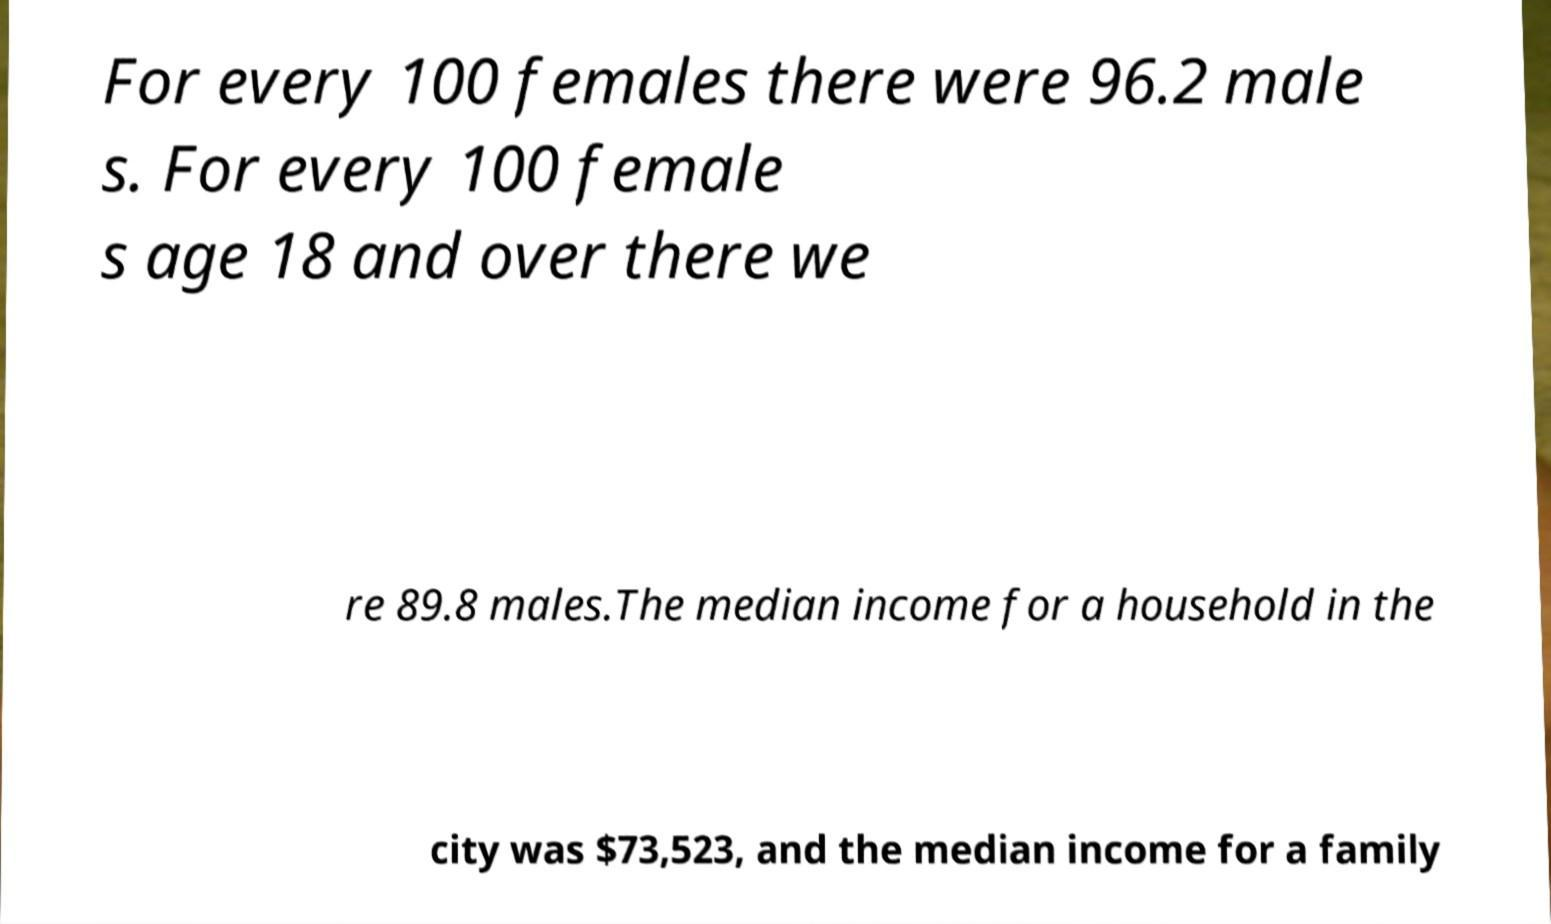I need the written content from this picture converted into text. Can you do that? For every 100 females there were 96.2 male s. For every 100 female s age 18 and over there we re 89.8 males.The median income for a household in the city was $73,523, and the median income for a family 